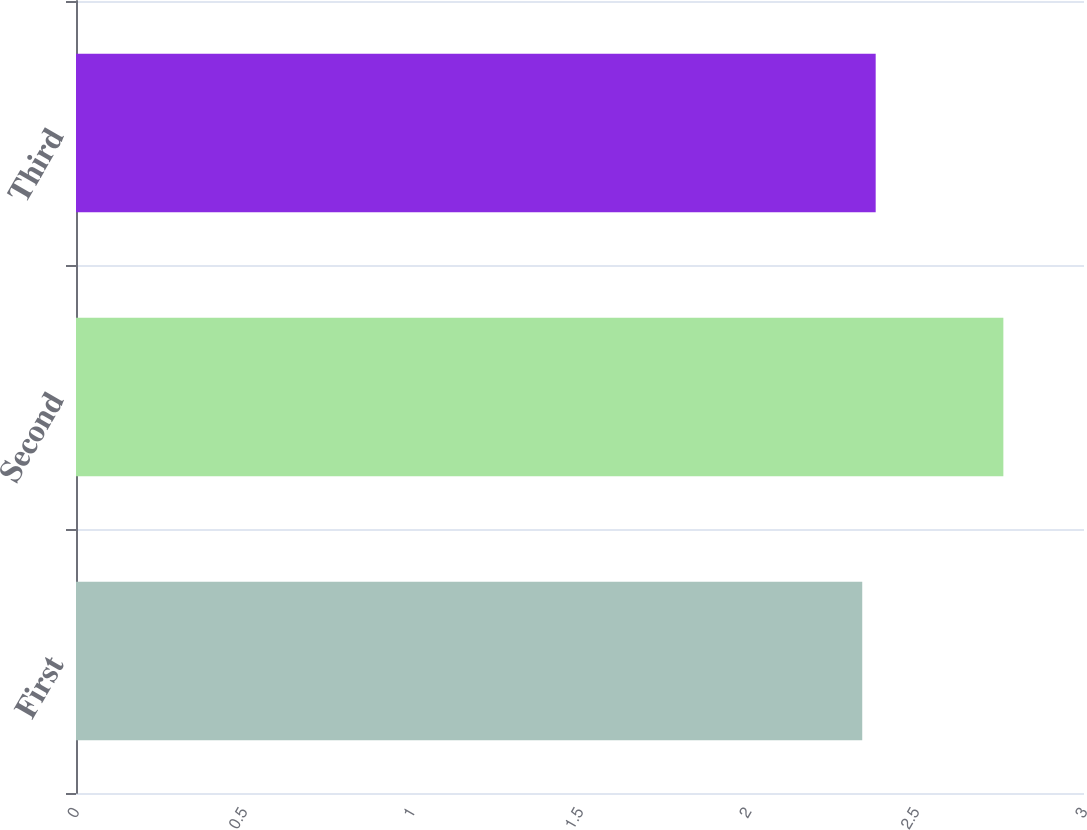Convert chart to OTSL. <chart><loc_0><loc_0><loc_500><loc_500><bar_chart><fcel>First<fcel>Second<fcel>Third<nl><fcel>2.34<fcel>2.76<fcel>2.38<nl></chart> 